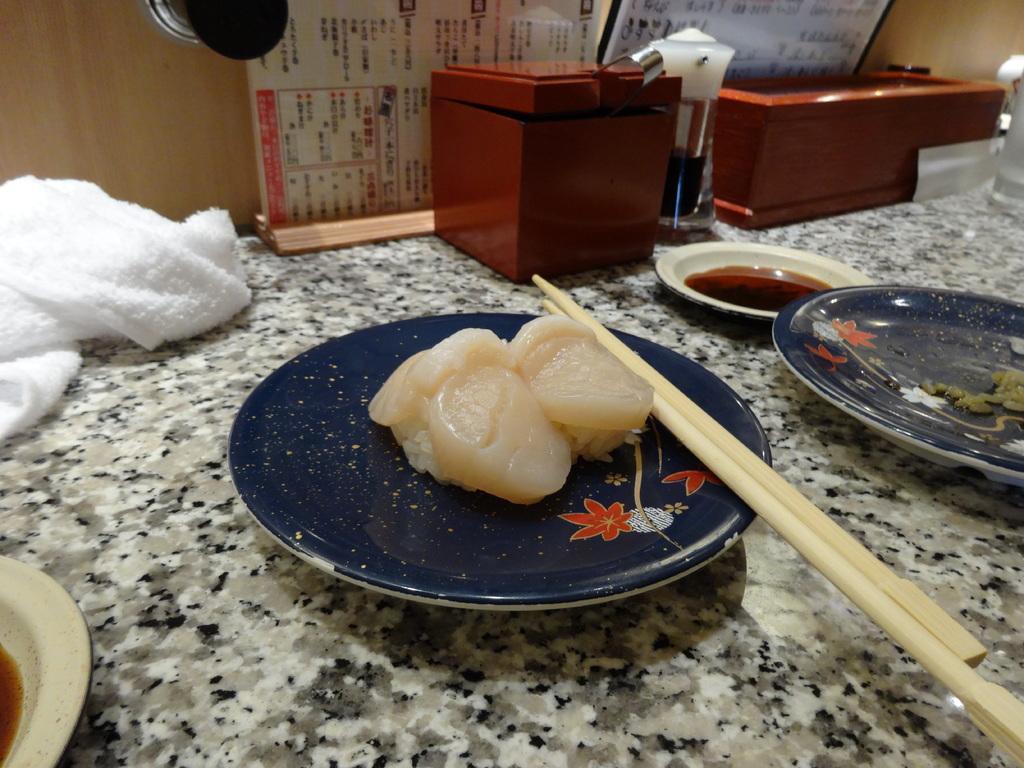Can you describe this image briefly? In this image we can see some food item which is placed in a plate there are tooth picks and there is another plate in which there is soup and in the background of the image there are some objects which are in brown color, there is towel, menu cards and there is a cardboard sheet. 